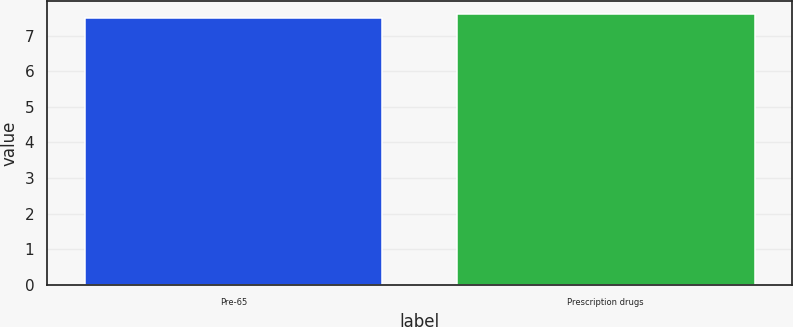Convert chart. <chart><loc_0><loc_0><loc_500><loc_500><bar_chart><fcel>Pre-65<fcel>Prescription drugs<nl><fcel>7.5<fcel>7.6<nl></chart> 